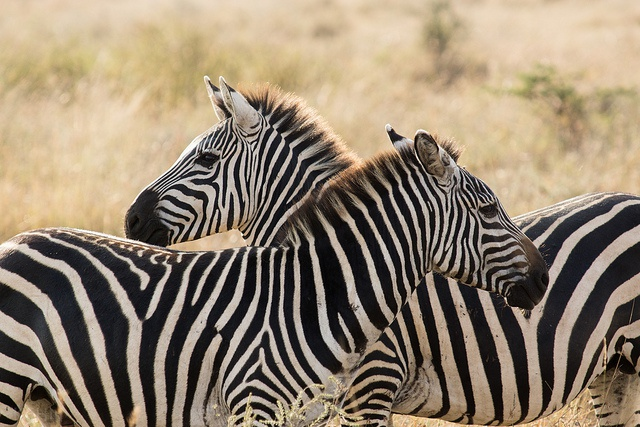Describe the objects in this image and their specific colors. I can see zebra in tan, black, darkgray, and gray tones and zebra in tan, black, and darkgray tones in this image. 